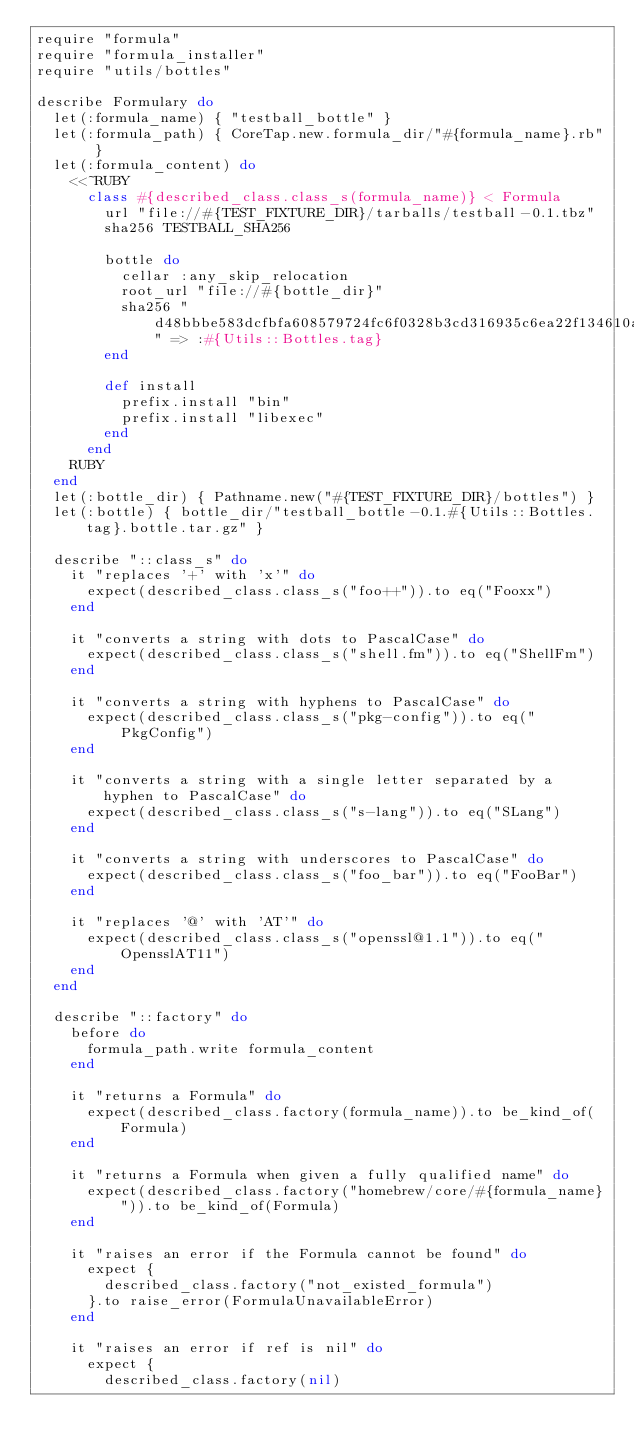Convert code to text. <code><loc_0><loc_0><loc_500><loc_500><_Ruby_>require "formula"
require "formula_installer"
require "utils/bottles"

describe Formulary do
  let(:formula_name) { "testball_bottle" }
  let(:formula_path) { CoreTap.new.formula_dir/"#{formula_name}.rb" }
  let(:formula_content) do
    <<~RUBY
      class #{described_class.class_s(formula_name)} < Formula
        url "file://#{TEST_FIXTURE_DIR}/tarballs/testball-0.1.tbz"
        sha256 TESTBALL_SHA256

        bottle do
          cellar :any_skip_relocation
          root_url "file://#{bottle_dir}"
          sha256 "d48bbbe583dcfbfa608579724fc6f0328b3cd316935c6ea22f134610aaf2952f" => :#{Utils::Bottles.tag}
        end

        def install
          prefix.install "bin"
          prefix.install "libexec"
        end
      end
    RUBY
  end
  let(:bottle_dir) { Pathname.new("#{TEST_FIXTURE_DIR}/bottles") }
  let(:bottle) { bottle_dir/"testball_bottle-0.1.#{Utils::Bottles.tag}.bottle.tar.gz" }

  describe "::class_s" do
    it "replaces '+' with 'x'" do
      expect(described_class.class_s("foo++")).to eq("Fooxx")
    end

    it "converts a string with dots to PascalCase" do
      expect(described_class.class_s("shell.fm")).to eq("ShellFm")
    end

    it "converts a string with hyphens to PascalCase" do
      expect(described_class.class_s("pkg-config")).to eq("PkgConfig")
    end

    it "converts a string with a single letter separated by a hyphen to PascalCase" do
      expect(described_class.class_s("s-lang")).to eq("SLang")
    end

    it "converts a string with underscores to PascalCase" do
      expect(described_class.class_s("foo_bar")).to eq("FooBar")
    end

    it "replaces '@' with 'AT'" do
      expect(described_class.class_s("openssl@1.1")).to eq("OpensslAT11")
    end
  end

  describe "::factory" do
    before do
      formula_path.write formula_content
    end

    it "returns a Formula" do
      expect(described_class.factory(formula_name)).to be_kind_of(Formula)
    end

    it "returns a Formula when given a fully qualified name" do
      expect(described_class.factory("homebrew/core/#{formula_name}")).to be_kind_of(Formula)
    end

    it "raises an error if the Formula cannot be found" do
      expect {
        described_class.factory("not_existed_formula")
      }.to raise_error(FormulaUnavailableError)
    end

    it "raises an error if ref is nil" do
      expect {
        described_class.factory(nil)</code> 